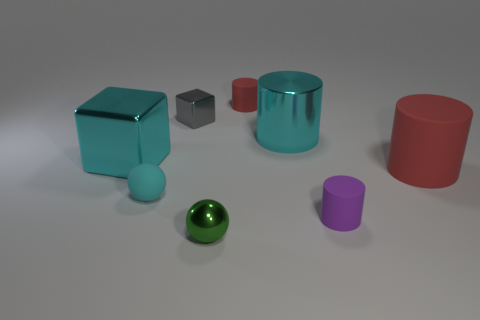Subtract 1 cylinders. How many cylinders are left? 3 Subtract all brown cylinders. Subtract all blue cubes. How many cylinders are left? 4 Add 1 big green shiny cubes. How many objects exist? 9 Subtract all spheres. How many objects are left? 6 Add 5 large yellow matte spheres. How many large yellow matte spheres exist? 5 Subtract 0 gray spheres. How many objects are left? 8 Subtract all purple metal blocks. Subtract all balls. How many objects are left? 6 Add 7 tiny red matte objects. How many tiny red matte objects are left? 8 